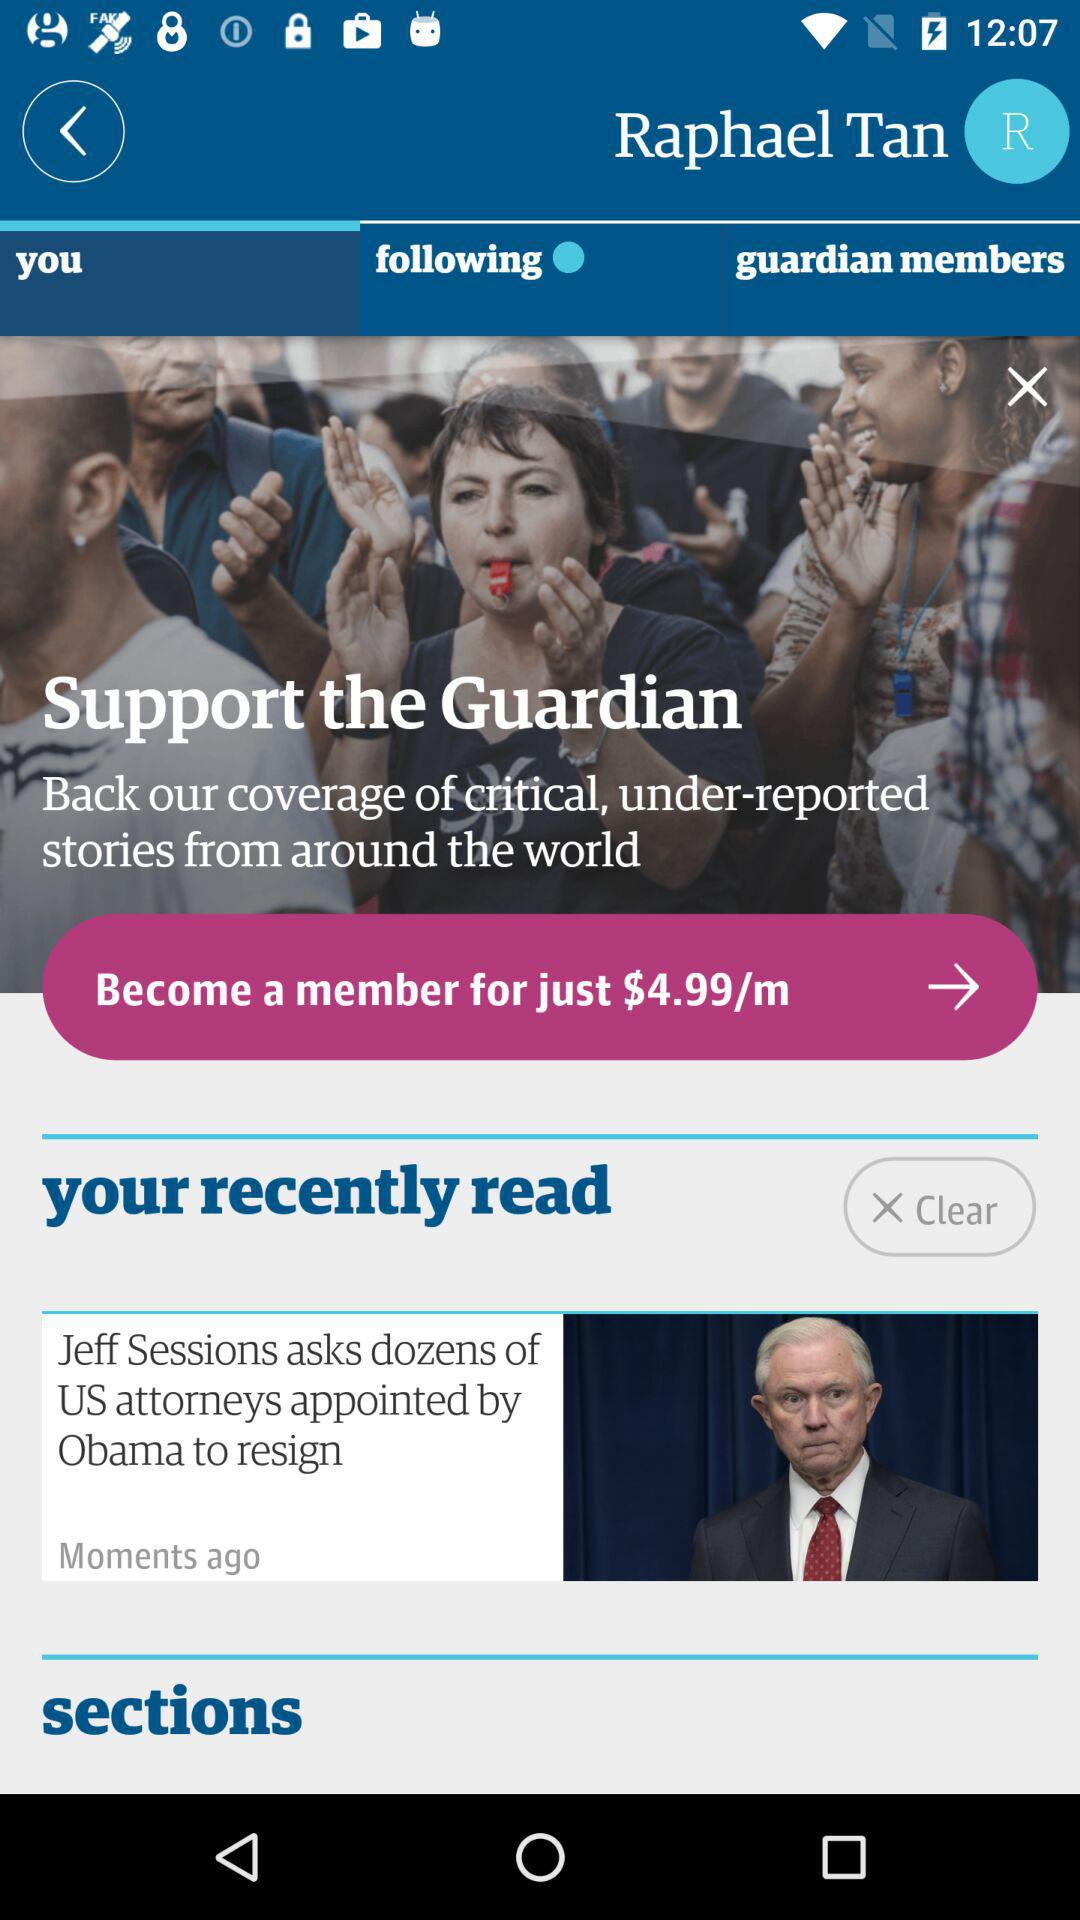What is the charge per month to become a member? The charge per month is $4.99. 